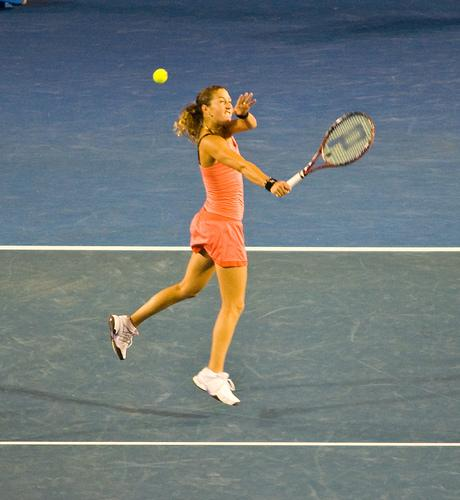Who supplied her tennis racket?

Choices:
A) wilson
B) nike
C) prince
D) puma prince 